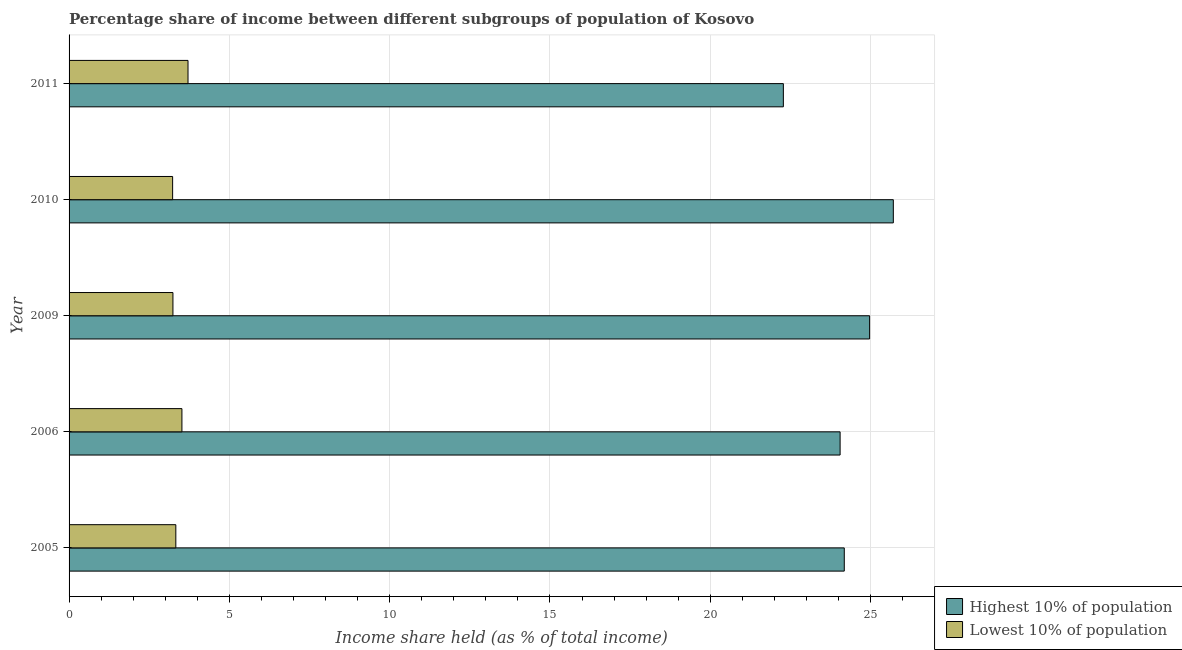How many bars are there on the 3rd tick from the top?
Give a very brief answer. 2. What is the label of the 1st group of bars from the top?
Provide a short and direct response. 2011. What is the income share held by lowest 10% of the population in 2010?
Offer a very short reply. 3.23. Across all years, what is the maximum income share held by lowest 10% of the population?
Offer a terse response. 3.71. Across all years, what is the minimum income share held by lowest 10% of the population?
Ensure brevity in your answer.  3.23. What is the total income share held by highest 10% of the population in the graph?
Your response must be concise. 121.19. What is the difference between the income share held by lowest 10% of the population in 2005 and that in 2011?
Keep it short and to the point. -0.38. What is the difference between the income share held by highest 10% of the population in 2005 and the income share held by lowest 10% of the population in 2011?
Make the answer very short. 20.47. What is the average income share held by lowest 10% of the population per year?
Ensure brevity in your answer.  3.41. In the year 2011, what is the difference between the income share held by lowest 10% of the population and income share held by highest 10% of the population?
Your response must be concise. -18.57. What is the ratio of the income share held by lowest 10% of the population in 2006 to that in 2010?
Your answer should be very brief. 1.09. Is the income share held by lowest 10% of the population in 2010 less than that in 2011?
Offer a terse response. Yes. What is the difference between the highest and the second highest income share held by lowest 10% of the population?
Provide a short and direct response. 0.19. What is the difference between the highest and the lowest income share held by lowest 10% of the population?
Provide a short and direct response. 0.48. In how many years, is the income share held by lowest 10% of the population greater than the average income share held by lowest 10% of the population taken over all years?
Your answer should be very brief. 2. Is the sum of the income share held by highest 10% of the population in 2006 and 2010 greater than the maximum income share held by lowest 10% of the population across all years?
Offer a terse response. Yes. What does the 1st bar from the top in 2011 represents?
Make the answer very short. Lowest 10% of population. What does the 1st bar from the bottom in 2006 represents?
Offer a terse response. Highest 10% of population. How many bars are there?
Offer a very short reply. 10. Are all the bars in the graph horizontal?
Offer a very short reply. Yes. How many years are there in the graph?
Your response must be concise. 5. What is the difference between two consecutive major ticks on the X-axis?
Offer a very short reply. 5. Are the values on the major ticks of X-axis written in scientific E-notation?
Keep it short and to the point. No. How many legend labels are there?
Offer a very short reply. 2. What is the title of the graph?
Offer a very short reply. Percentage share of income between different subgroups of population of Kosovo. Does "Exports of goods" appear as one of the legend labels in the graph?
Your answer should be very brief. No. What is the label or title of the X-axis?
Provide a short and direct response. Income share held (as % of total income). What is the Income share held (as % of total income) in Highest 10% of population in 2005?
Ensure brevity in your answer.  24.18. What is the Income share held (as % of total income) of Lowest 10% of population in 2005?
Give a very brief answer. 3.33. What is the Income share held (as % of total income) in Highest 10% of population in 2006?
Provide a short and direct response. 24.05. What is the Income share held (as % of total income) of Lowest 10% of population in 2006?
Your response must be concise. 3.52. What is the Income share held (as % of total income) of Highest 10% of population in 2009?
Offer a terse response. 24.97. What is the Income share held (as % of total income) in Lowest 10% of population in 2009?
Make the answer very short. 3.24. What is the Income share held (as % of total income) of Highest 10% of population in 2010?
Keep it short and to the point. 25.71. What is the Income share held (as % of total income) in Lowest 10% of population in 2010?
Your response must be concise. 3.23. What is the Income share held (as % of total income) of Highest 10% of population in 2011?
Ensure brevity in your answer.  22.28. What is the Income share held (as % of total income) of Lowest 10% of population in 2011?
Keep it short and to the point. 3.71. Across all years, what is the maximum Income share held (as % of total income) of Highest 10% of population?
Provide a succinct answer. 25.71. Across all years, what is the maximum Income share held (as % of total income) of Lowest 10% of population?
Ensure brevity in your answer.  3.71. Across all years, what is the minimum Income share held (as % of total income) of Highest 10% of population?
Your response must be concise. 22.28. Across all years, what is the minimum Income share held (as % of total income) in Lowest 10% of population?
Provide a short and direct response. 3.23. What is the total Income share held (as % of total income) in Highest 10% of population in the graph?
Ensure brevity in your answer.  121.19. What is the total Income share held (as % of total income) of Lowest 10% of population in the graph?
Keep it short and to the point. 17.03. What is the difference between the Income share held (as % of total income) in Highest 10% of population in 2005 and that in 2006?
Give a very brief answer. 0.13. What is the difference between the Income share held (as % of total income) of Lowest 10% of population in 2005 and that in 2006?
Your answer should be very brief. -0.19. What is the difference between the Income share held (as % of total income) of Highest 10% of population in 2005 and that in 2009?
Provide a succinct answer. -0.79. What is the difference between the Income share held (as % of total income) of Lowest 10% of population in 2005 and that in 2009?
Your answer should be compact. 0.09. What is the difference between the Income share held (as % of total income) in Highest 10% of population in 2005 and that in 2010?
Your response must be concise. -1.53. What is the difference between the Income share held (as % of total income) in Lowest 10% of population in 2005 and that in 2010?
Offer a terse response. 0.1. What is the difference between the Income share held (as % of total income) in Lowest 10% of population in 2005 and that in 2011?
Offer a terse response. -0.38. What is the difference between the Income share held (as % of total income) of Highest 10% of population in 2006 and that in 2009?
Your answer should be compact. -0.92. What is the difference between the Income share held (as % of total income) in Lowest 10% of population in 2006 and that in 2009?
Keep it short and to the point. 0.28. What is the difference between the Income share held (as % of total income) of Highest 10% of population in 2006 and that in 2010?
Provide a succinct answer. -1.66. What is the difference between the Income share held (as % of total income) in Lowest 10% of population in 2006 and that in 2010?
Ensure brevity in your answer.  0.29. What is the difference between the Income share held (as % of total income) in Highest 10% of population in 2006 and that in 2011?
Ensure brevity in your answer.  1.77. What is the difference between the Income share held (as % of total income) of Lowest 10% of population in 2006 and that in 2011?
Offer a terse response. -0.19. What is the difference between the Income share held (as % of total income) of Highest 10% of population in 2009 and that in 2010?
Provide a succinct answer. -0.74. What is the difference between the Income share held (as % of total income) in Highest 10% of population in 2009 and that in 2011?
Provide a short and direct response. 2.69. What is the difference between the Income share held (as % of total income) in Lowest 10% of population in 2009 and that in 2011?
Provide a short and direct response. -0.47. What is the difference between the Income share held (as % of total income) in Highest 10% of population in 2010 and that in 2011?
Your response must be concise. 3.43. What is the difference between the Income share held (as % of total income) in Lowest 10% of population in 2010 and that in 2011?
Provide a short and direct response. -0.48. What is the difference between the Income share held (as % of total income) in Highest 10% of population in 2005 and the Income share held (as % of total income) in Lowest 10% of population in 2006?
Offer a very short reply. 20.66. What is the difference between the Income share held (as % of total income) in Highest 10% of population in 2005 and the Income share held (as % of total income) in Lowest 10% of population in 2009?
Make the answer very short. 20.94. What is the difference between the Income share held (as % of total income) in Highest 10% of population in 2005 and the Income share held (as % of total income) in Lowest 10% of population in 2010?
Give a very brief answer. 20.95. What is the difference between the Income share held (as % of total income) of Highest 10% of population in 2005 and the Income share held (as % of total income) of Lowest 10% of population in 2011?
Offer a terse response. 20.47. What is the difference between the Income share held (as % of total income) in Highest 10% of population in 2006 and the Income share held (as % of total income) in Lowest 10% of population in 2009?
Give a very brief answer. 20.81. What is the difference between the Income share held (as % of total income) of Highest 10% of population in 2006 and the Income share held (as % of total income) of Lowest 10% of population in 2010?
Keep it short and to the point. 20.82. What is the difference between the Income share held (as % of total income) in Highest 10% of population in 2006 and the Income share held (as % of total income) in Lowest 10% of population in 2011?
Your answer should be compact. 20.34. What is the difference between the Income share held (as % of total income) in Highest 10% of population in 2009 and the Income share held (as % of total income) in Lowest 10% of population in 2010?
Ensure brevity in your answer.  21.74. What is the difference between the Income share held (as % of total income) of Highest 10% of population in 2009 and the Income share held (as % of total income) of Lowest 10% of population in 2011?
Keep it short and to the point. 21.26. What is the average Income share held (as % of total income) in Highest 10% of population per year?
Your answer should be compact. 24.24. What is the average Income share held (as % of total income) in Lowest 10% of population per year?
Provide a succinct answer. 3.41. In the year 2005, what is the difference between the Income share held (as % of total income) in Highest 10% of population and Income share held (as % of total income) in Lowest 10% of population?
Provide a succinct answer. 20.85. In the year 2006, what is the difference between the Income share held (as % of total income) in Highest 10% of population and Income share held (as % of total income) in Lowest 10% of population?
Offer a very short reply. 20.53. In the year 2009, what is the difference between the Income share held (as % of total income) of Highest 10% of population and Income share held (as % of total income) of Lowest 10% of population?
Your response must be concise. 21.73. In the year 2010, what is the difference between the Income share held (as % of total income) of Highest 10% of population and Income share held (as % of total income) of Lowest 10% of population?
Ensure brevity in your answer.  22.48. In the year 2011, what is the difference between the Income share held (as % of total income) of Highest 10% of population and Income share held (as % of total income) of Lowest 10% of population?
Provide a short and direct response. 18.57. What is the ratio of the Income share held (as % of total income) of Highest 10% of population in 2005 to that in 2006?
Your answer should be very brief. 1.01. What is the ratio of the Income share held (as % of total income) in Lowest 10% of population in 2005 to that in 2006?
Ensure brevity in your answer.  0.95. What is the ratio of the Income share held (as % of total income) in Highest 10% of population in 2005 to that in 2009?
Your response must be concise. 0.97. What is the ratio of the Income share held (as % of total income) in Lowest 10% of population in 2005 to that in 2009?
Keep it short and to the point. 1.03. What is the ratio of the Income share held (as % of total income) of Highest 10% of population in 2005 to that in 2010?
Provide a succinct answer. 0.94. What is the ratio of the Income share held (as % of total income) of Lowest 10% of population in 2005 to that in 2010?
Offer a very short reply. 1.03. What is the ratio of the Income share held (as % of total income) in Highest 10% of population in 2005 to that in 2011?
Provide a succinct answer. 1.09. What is the ratio of the Income share held (as % of total income) of Lowest 10% of population in 2005 to that in 2011?
Offer a terse response. 0.9. What is the ratio of the Income share held (as % of total income) of Highest 10% of population in 2006 to that in 2009?
Offer a very short reply. 0.96. What is the ratio of the Income share held (as % of total income) of Lowest 10% of population in 2006 to that in 2009?
Provide a short and direct response. 1.09. What is the ratio of the Income share held (as % of total income) of Highest 10% of population in 2006 to that in 2010?
Offer a very short reply. 0.94. What is the ratio of the Income share held (as % of total income) of Lowest 10% of population in 2006 to that in 2010?
Ensure brevity in your answer.  1.09. What is the ratio of the Income share held (as % of total income) in Highest 10% of population in 2006 to that in 2011?
Offer a very short reply. 1.08. What is the ratio of the Income share held (as % of total income) in Lowest 10% of population in 2006 to that in 2011?
Your response must be concise. 0.95. What is the ratio of the Income share held (as % of total income) in Highest 10% of population in 2009 to that in 2010?
Give a very brief answer. 0.97. What is the ratio of the Income share held (as % of total income) of Lowest 10% of population in 2009 to that in 2010?
Offer a very short reply. 1. What is the ratio of the Income share held (as % of total income) in Highest 10% of population in 2009 to that in 2011?
Your response must be concise. 1.12. What is the ratio of the Income share held (as % of total income) of Lowest 10% of population in 2009 to that in 2011?
Your answer should be compact. 0.87. What is the ratio of the Income share held (as % of total income) of Highest 10% of population in 2010 to that in 2011?
Offer a very short reply. 1.15. What is the ratio of the Income share held (as % of total income) of Lowest 10% of population in 2010 to that in 2011?
Provide a succinct answer. 0.87. What is the difference between the highest and the second highest Income share held (as % of total income) of Highest 10% of population?
Keep it short and to the point. 0.74. What is the difference between the highest and the second highest Income share held (as % of total income) in Lowest 10% of population?
Make the answer very short. 0.19. What is the difference between the highest and the lowest Income share held (as % of total income) of Highest 10% of population?
Provide a short and direct response. 3.43. What is the difference between the highest and the lowest Income share held (as % of total income) of Lowest 10% of population?
Ensure brevity in your answer.  0.48. 